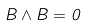<formula> <loc_0><loc_0><loc_500><loc_500>B \wedge B = 0</formula> 